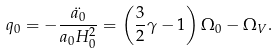Convert formula to latex. <formula><loc_0><loc_0><loc_500><loc_500>q _ { 0 } = - \frac { \ddot { a _ { 0 } } } { a _ { 0 } H _ { 0 } ^ { 2 } } = \left ( \frac { 3 } { 2 } \gamma - 1 \right ) \Omega _ { 0 } - \Omega _ { V } .</formula> 